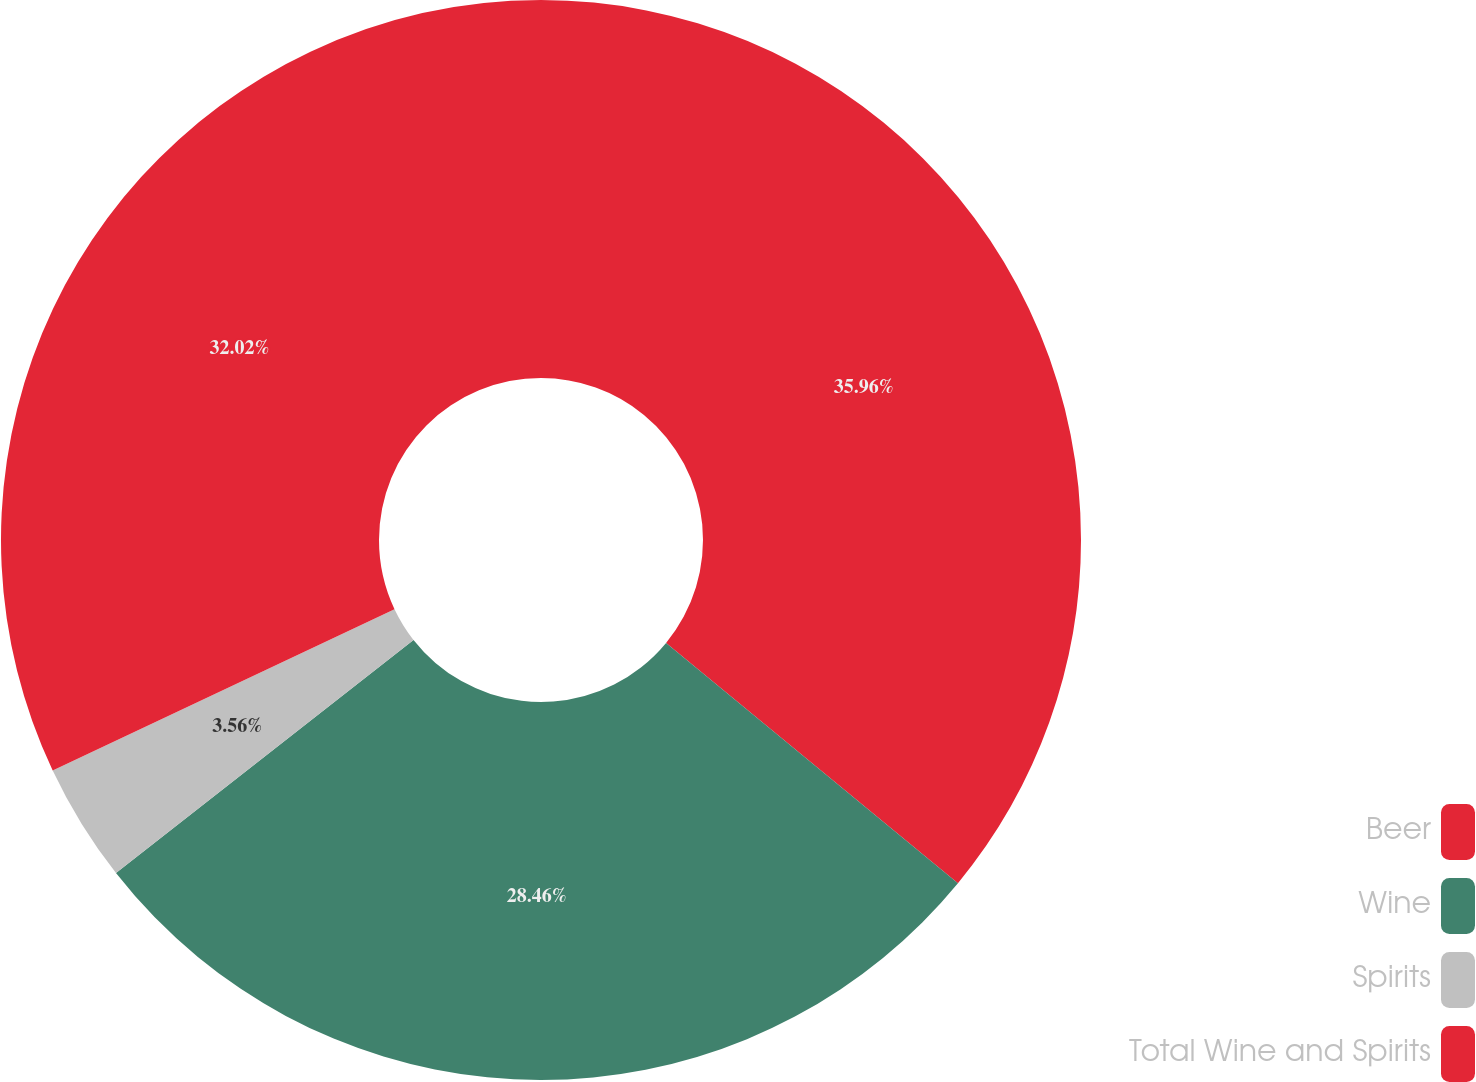Convert chart. <chart><loc_0><loc_0><loc_500><loc_500><pie_chart><fcel>Beer<fcel>Wine<fcel>Spirits<fcel>Total Wine and Spirits<nl><fcel>35.96%<fcel>28.46%<fcel>3.56%<fcel>32.02%<nl></chart> 